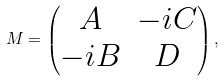<formula> <loc_0><loc_0><loc_500><loc_500>M = \begin{pmatrix} A & - i C \\ - i B & D \end{pmatrix} ,</formula> 